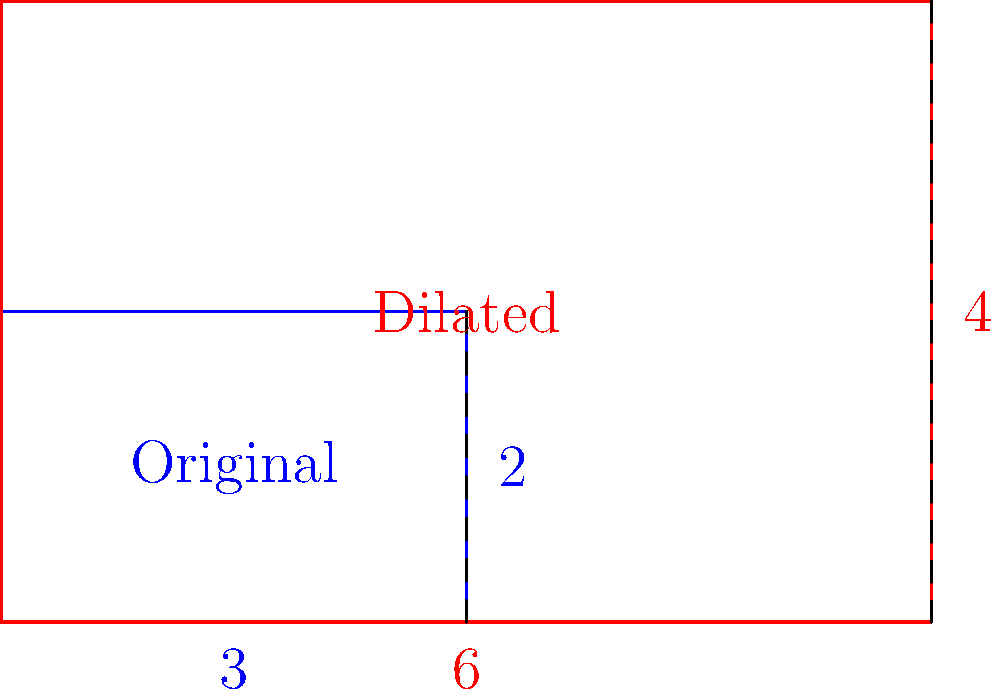As an editor overseeing a veteran author's work on transformational geometry, you come across a section discussing the effects of dilation on polygons. The author has included the diagram above, showing a rectangle and its dilated image with a scale factor of 2. How would you advise the author to explain the relationship between the scale factor and the changes in the rectangle's area and perimeter? To provide proper feedback to the author, we should consider the following steps:

1. Effect on side lengths:
   - Original rectangle: 3 units by 2 units
   - Dilated rectangle: 6 units by 4 units
   - Each side is multiplied by the scale factor (2)

2. Effect on perimeter:
   - Original perimeter = $2(3 + 2) = 10$ units
   - Dilated perimeter = $2(6 + 4) = 20$ units
   - The perimeter is multiplied by the scale factor: $20 = 10 \times 2$

3. Effect on area:
   - Original area = $3 \times 2 = 6$ square units
   - Dilated area = $6 \times 4 = 24$ square units
   - The area is multiplied by the square of the scale factor: $24 = 6 \times 2^2$

4. Generalization:
   - For a scale factor $k$:
     - Side lengths are multiplied by $k$
     - Perimeter is multiplied by $k$
     - Area is multiplied by $k^2$

5. Explanation for the author:
   The author should clearly state that when a polygon is dilated by a scale factor $k$:
   - Each side length is multiplied by $k$
   - The perimeter is multiplied by $k$
   - The area is multiplied by $k^2$

   This relationship holds true for all polygons, not just rectangles.
Answer: Advise author to explain: dilation by factor $k$ multiplies side lengths and perimeter by $k$, area by $k^2$. 